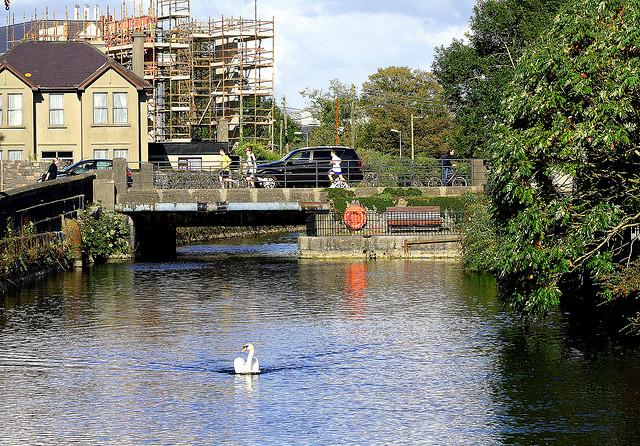Why is he running on the bridge? Please explain your reasoning. stay dry. He appears to be purposely on a run for exercise, and running makes it faster. 